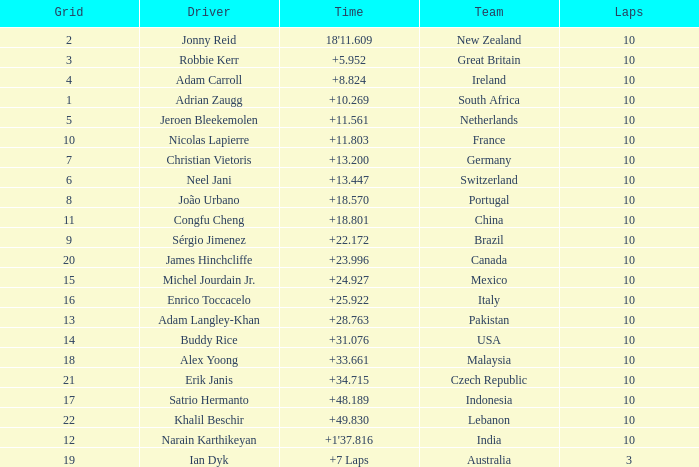What is the Grid number for the Team from Italy? 1.0. 